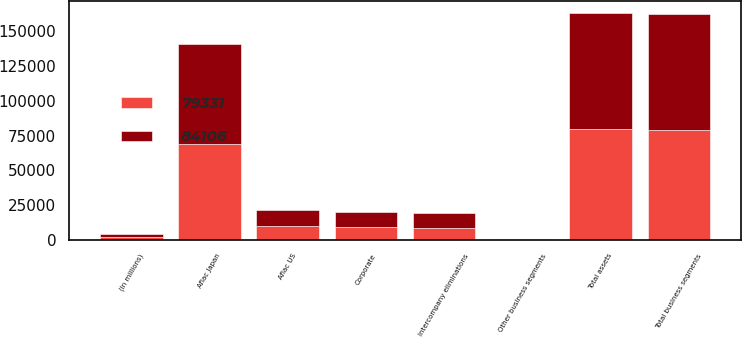Convert chart to OTSL. <chart><loc_0><loc_0><loc_500><loc_500><stacked_bar_chart><ecel><fcel>(In millions)<fcel>Aflac Japan<fcel>Aflac US<fcel>Other business segments<fcel>Total business segments<fcel>Corporate<fcel>Intercompany eliminations<fcel>Total assets<nl><fcel>84106<fcel>2009<fcel>71639<fcel>11779<fcel>142<fcel>83560<fcel>11261<fcel>10715<fcel>84106<nl><fcel>79331<fcel>2008<fcel>69141<fcel>9679<fcel>166<fcel>78986<fcel>8716<fcel>8371<fcel>79331<nl></chart> 